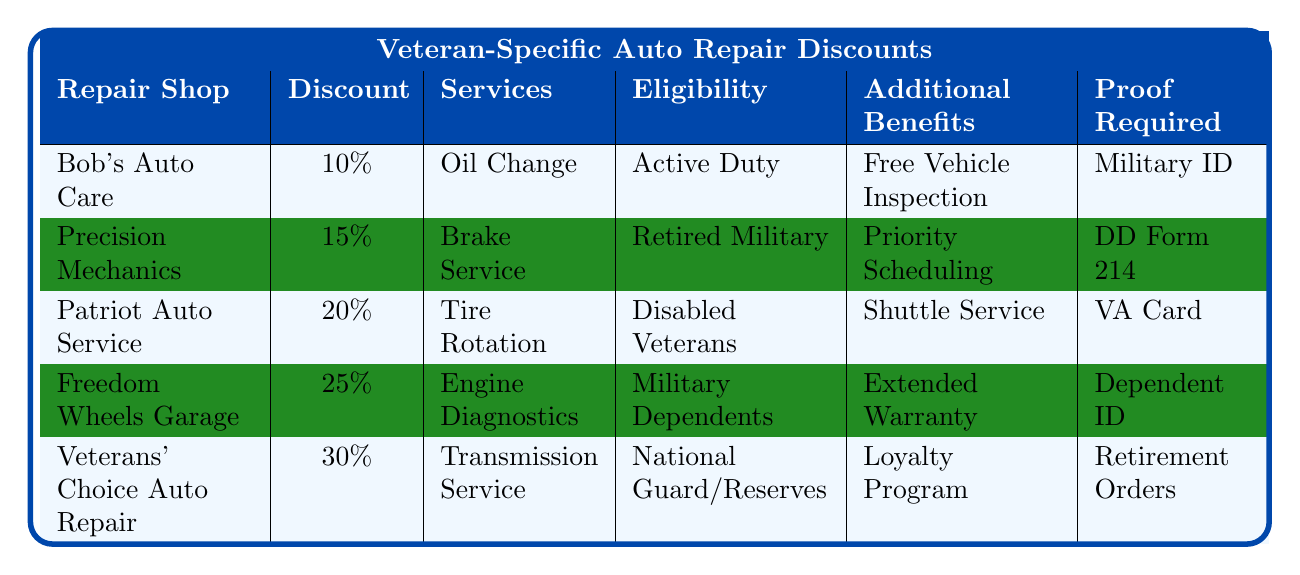What is the discount percentage offered by Patriot Auto Service? The table lists the discount percentages for each auto repair shop. Under the row for Patriot Auto Service, the discount percentage is shown as 20%.
Answer: 20% Which auto repair shop offers the highest discount? Looking at the discount percentages in the table, Veterans' Choice Auto Repair has the highest discount at 30%.
Answer: Veterans' Choice Auto Repair How many services are covered by Freedom Wheels Garage? The table indicates that Freedom Wheels Garage covers one service which is Engine Diagnostics.
Answer: 1 Are military dependents eligible for any discounts? The eligibility requirements listed in the table include Military Dependents, confirming that they are eligible for a discount.
Answer: Yes What proof is required by Precision Mechanics? The table states that the proof required by Precision Mechanics is a DD Form 214.
Answer: DD Form 214 If a disabled veteran goes to Patriot Auto Service, what additional benefit can they receive? According to the table, disabled veterans using Patriot Auto Service can receive Shuttle Service as an additional benefit.
Answer: Shuttle Service Calculate the average discount percentage across all the listed auto repair shops. The discounts are 10%, 15%, 20%, 25%, and 30%. Sum these values: 10 + 15 + 20 + 25 + 30 = 100. There are 5 shops, so the average is 100 / 5 = 20%.
Answer: 20% Is there an auto repair shop that requires a retirement order as proof? The table shows that Veterans' Choice Auto Repair requires Retirement Orders as proof, answering the question affirmatively.
Answer: Yes Which additional benefit is offered by Bob's Auto Care? Bob's Auto Care provides a Free Vehicle Inspection as listed in the table.
Answer: Free Vehicle Inspection What services does a national guard/reserve member qualify for at Veterans' Choice Auto Repair? The table indicates that Veterans' Choice Auto Repair covers Transmission Service for national guard/reserve members.
Answer: Transmission Service 